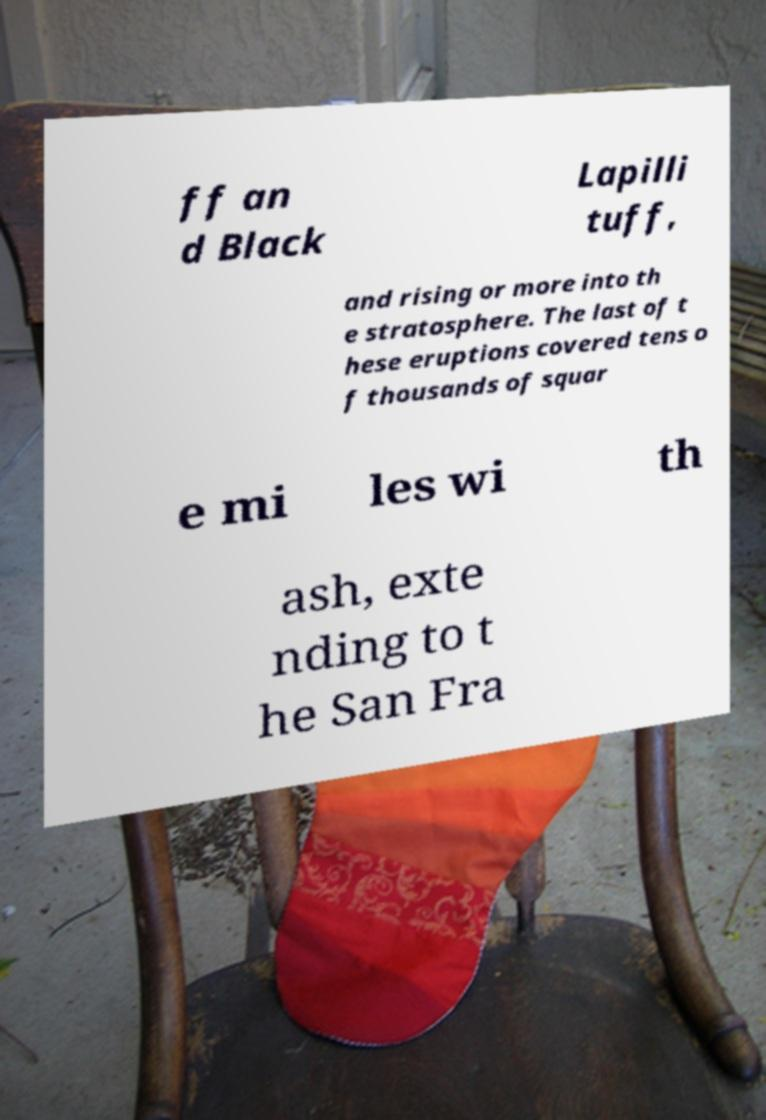Please read and relay the text visible in this image. What does it say? ff an d Black Lapilli tuff, and rising or more into th e stratosphere. The last of t hese eruptions covered tens o f thousands of squar e mi les wi th ash, exte nding to t he San Fra 